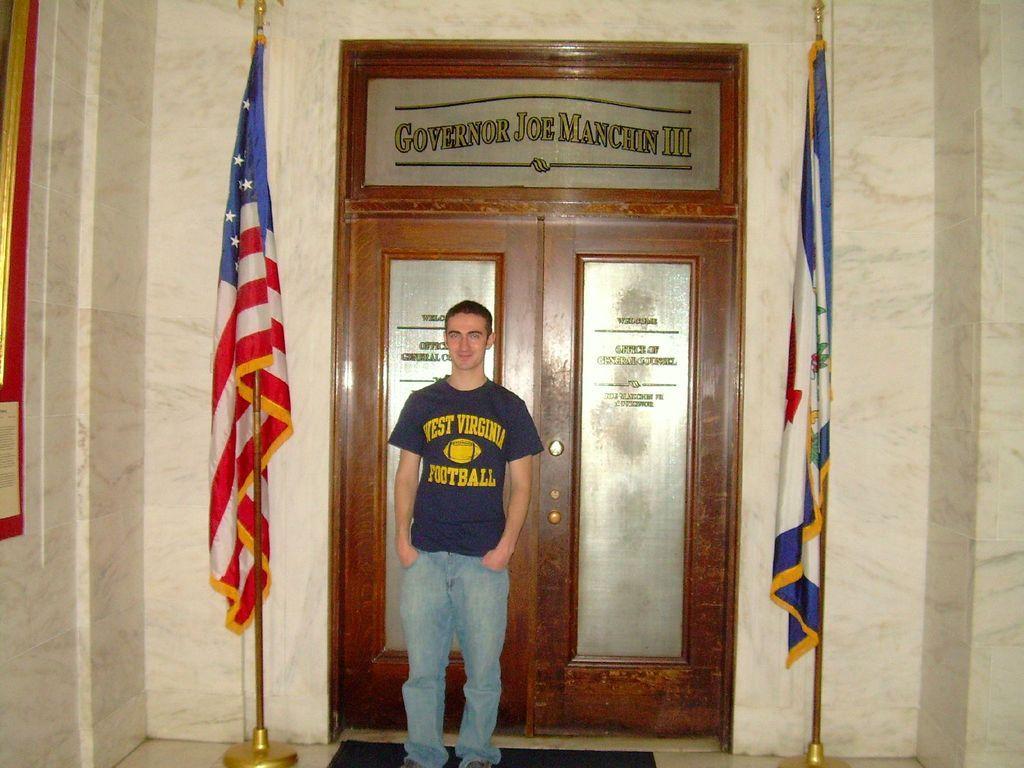Can you describe this image briefly? In the middle of the image there is a man with blue t-shirt is standing. Behind him there is a door with something written on it. And besides him there are poles with flags. And also there is a wall in the background. 